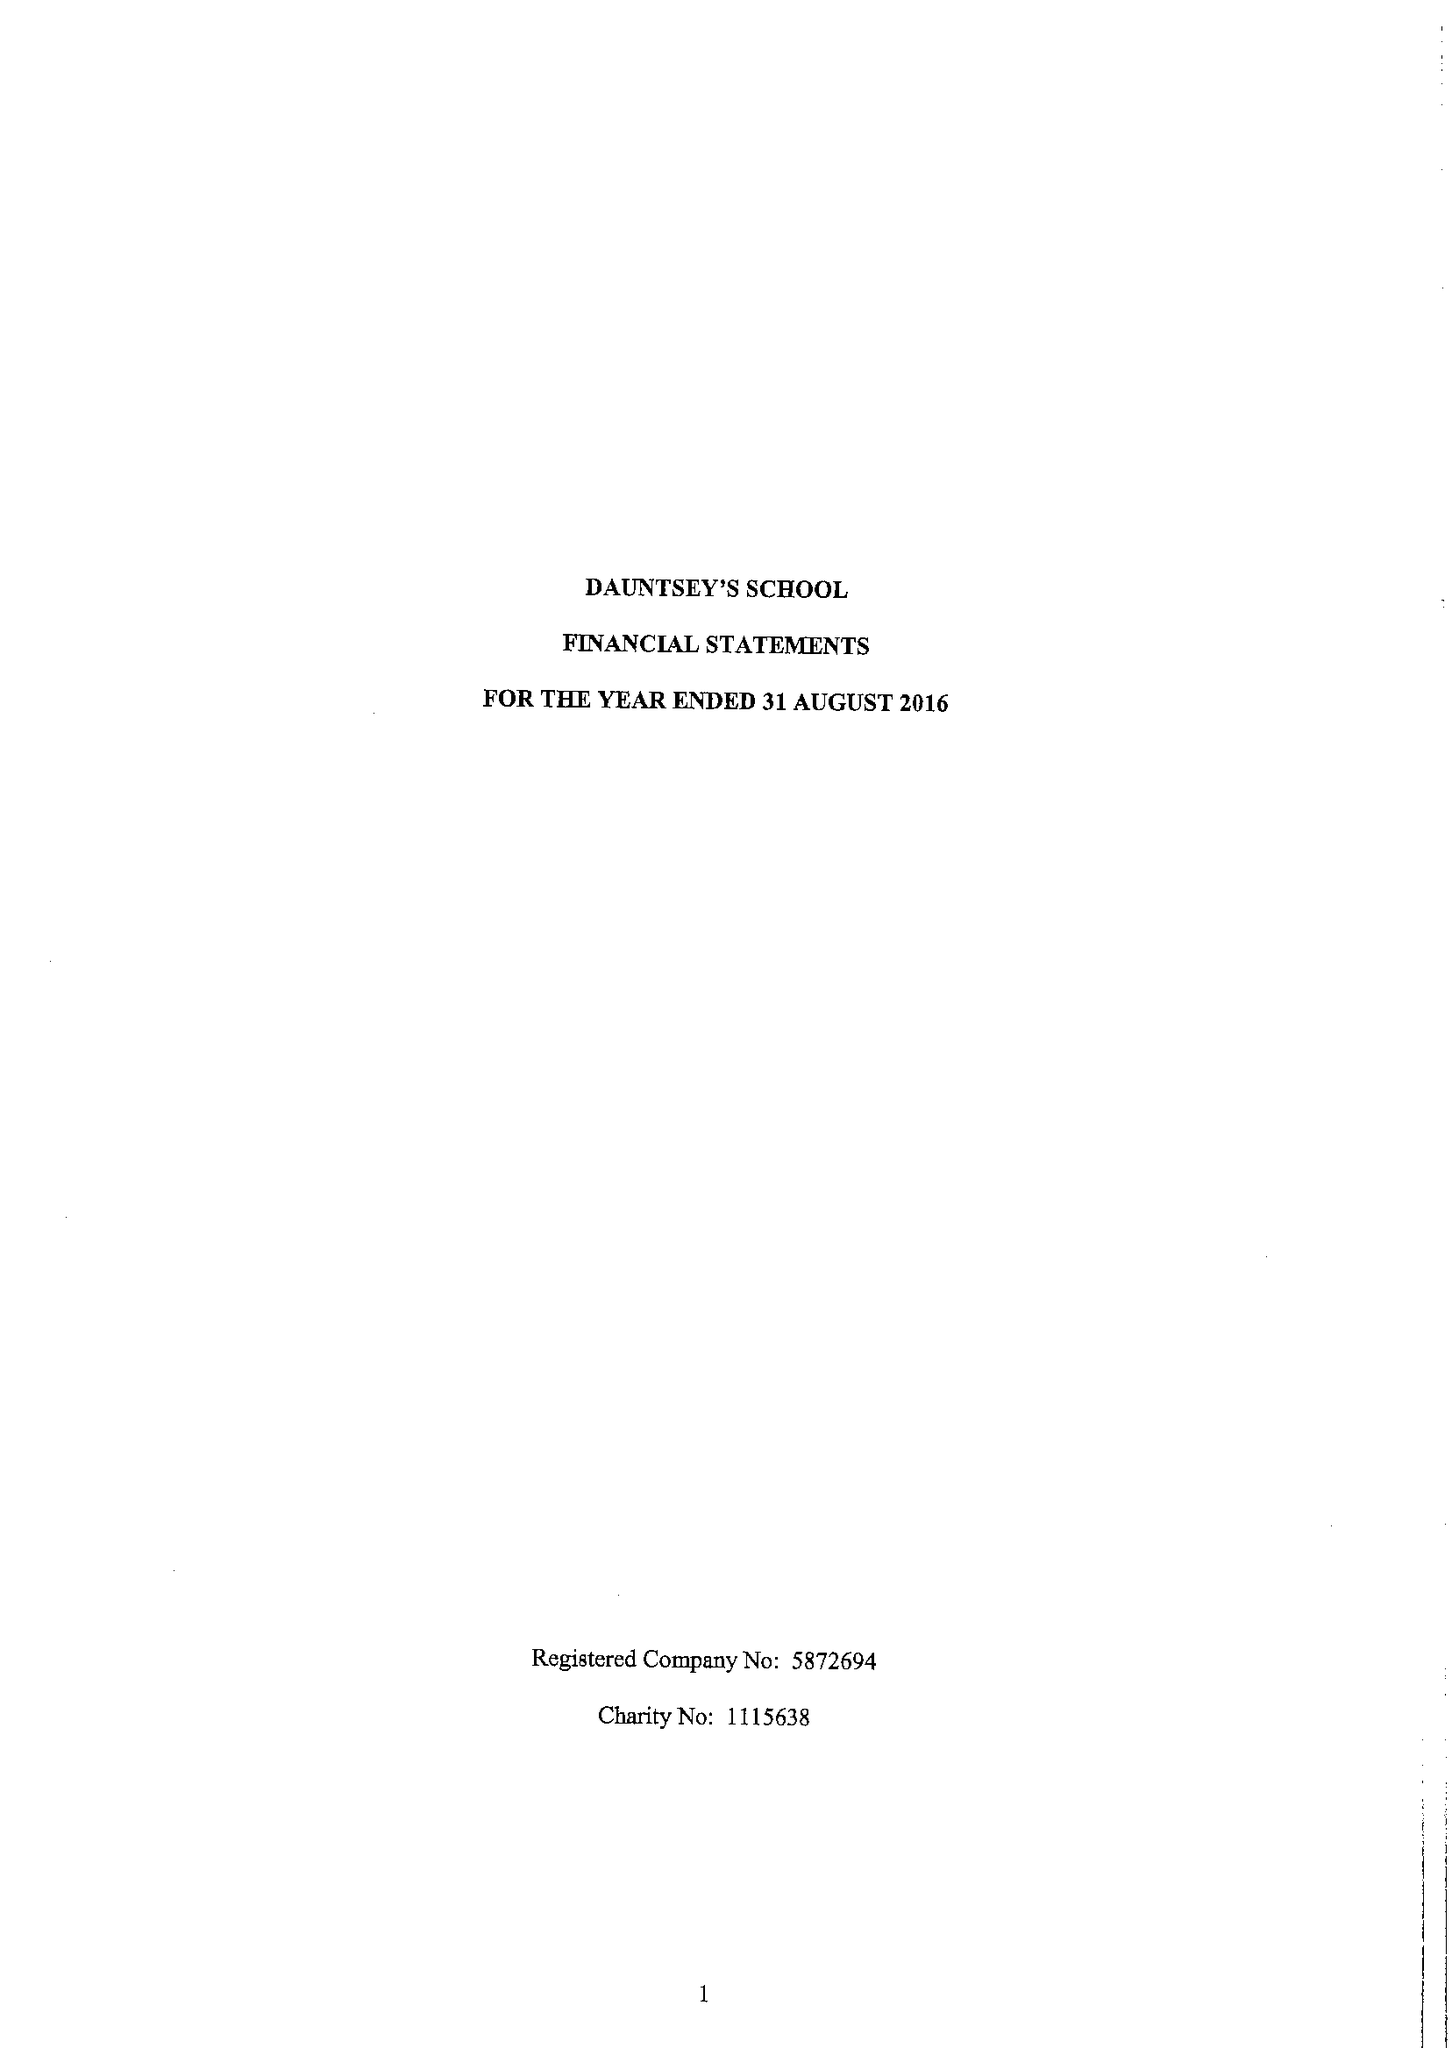What is the value for the charity_number?
Answer the question using a single word or phrase. 1115638 